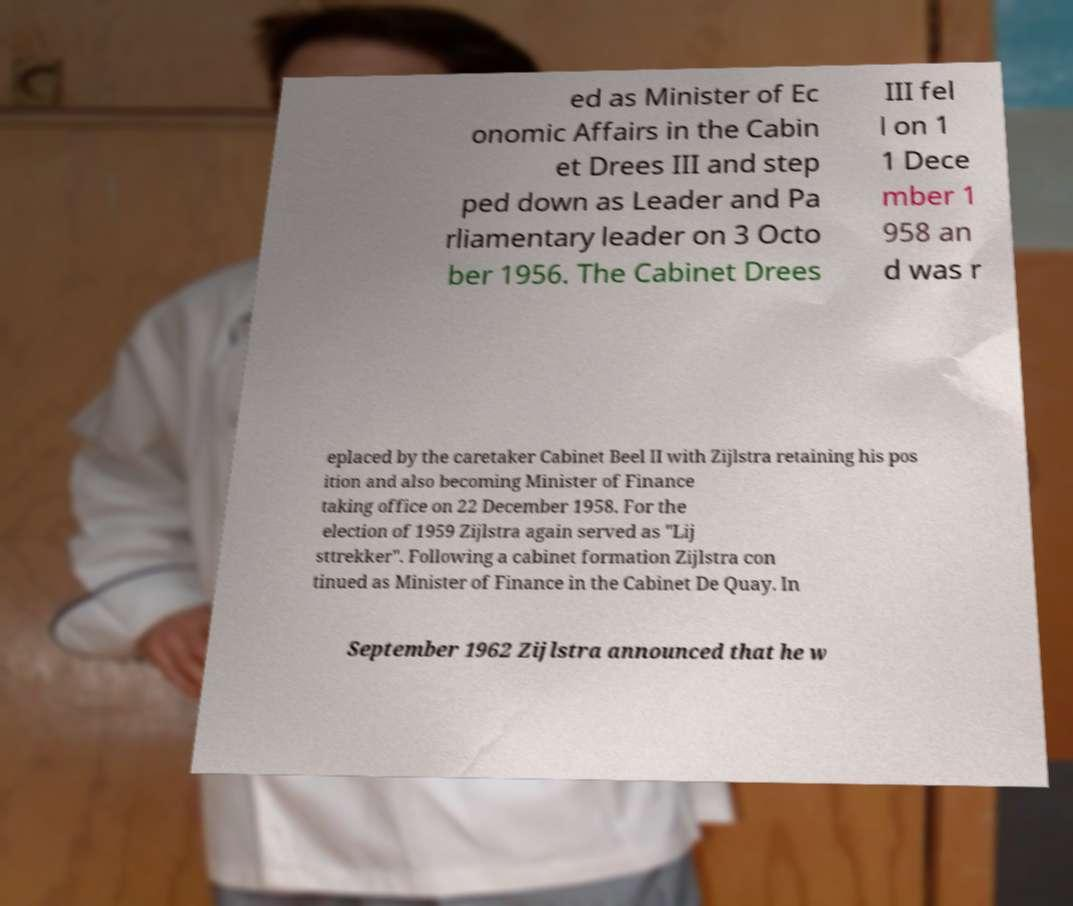For documentation purposes, I need the text within this image transcribed. Could you provide that? ed as Minister of Ec onomic Affairs in the Cabin et Drees III and step ped down as Leader and Pa rliamentary leader on 3 Octo ber 1956. The Cabinet Drees III fel l on 1 1 Dece mber 1 958 an d was r eplaced by the caretaker Cabinet Beel II with Zijlstra retaining his pos ition and also becoming Minister of Finance taking office on 22 December 1958. For the election of 1959 Zijlstra again served as "Lij sttrekker". Following a cabinet formation Zijlstra con tinued as Minister of Finance in the Cabinet De Quay. In September 1962 Zijlstra announced that he w 